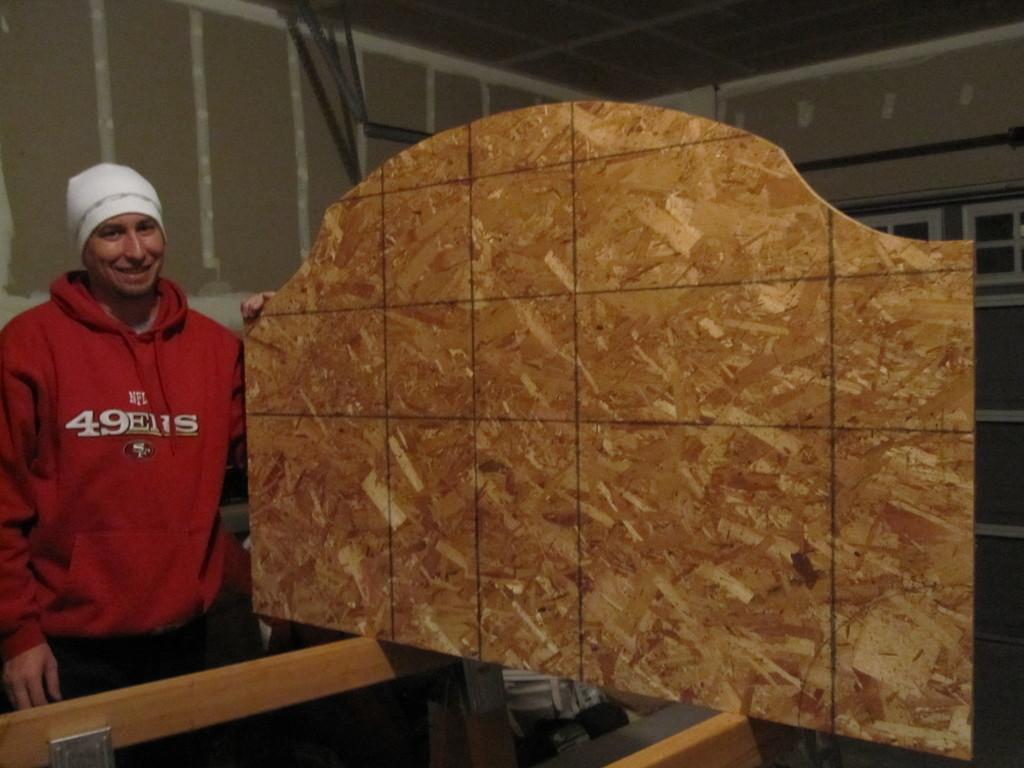Could you give a brief overview of what you see in this image? In this image we can see a person wearing a red T-shirt and he is holding a wooden structure. In the background there is a wall. 